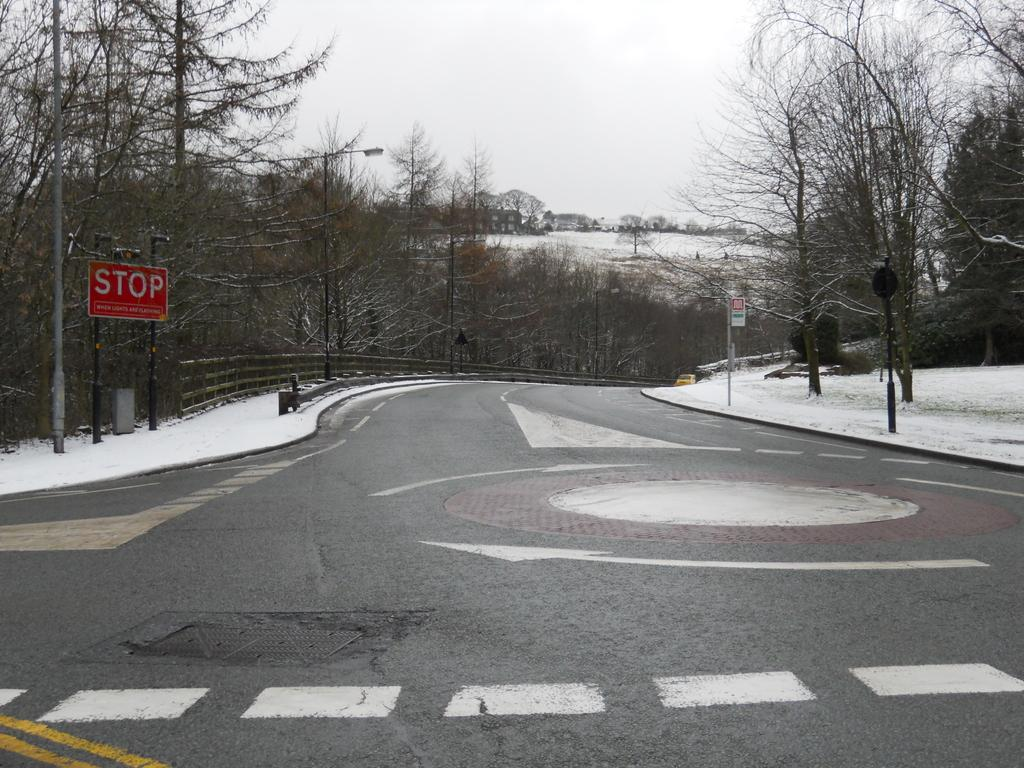What type of vegetation can be seen in the image? There are trees in the image. What is the weather like in the image? There is snow in the image, indicating a cold and likely wintery scene. What type of structure is present in the image? There is a sign pole, a fence, and a street lamp in the image. What is visible at the top of the image? The sky is visible at the top of the image. Where is the bomb located in the image? There is no bomb present in the image. What shape is the hill in the image? There is no hill present in the image. 